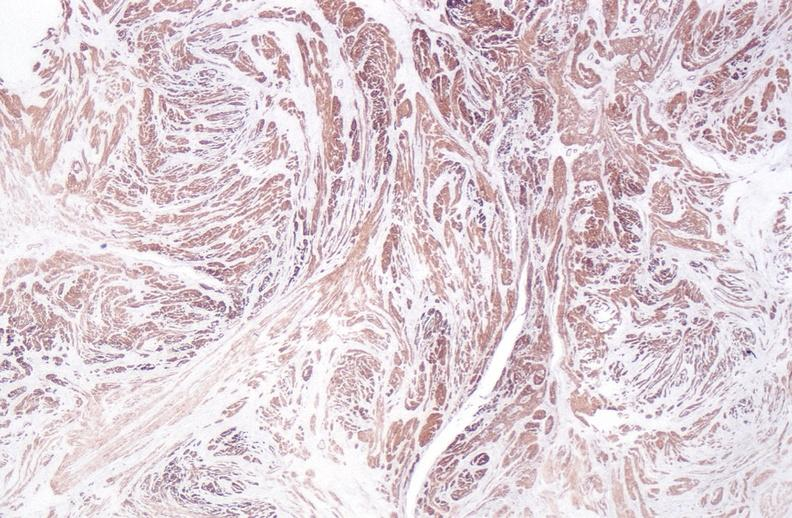s serous cyst present?
Answer the question using a single word or phrase. No 